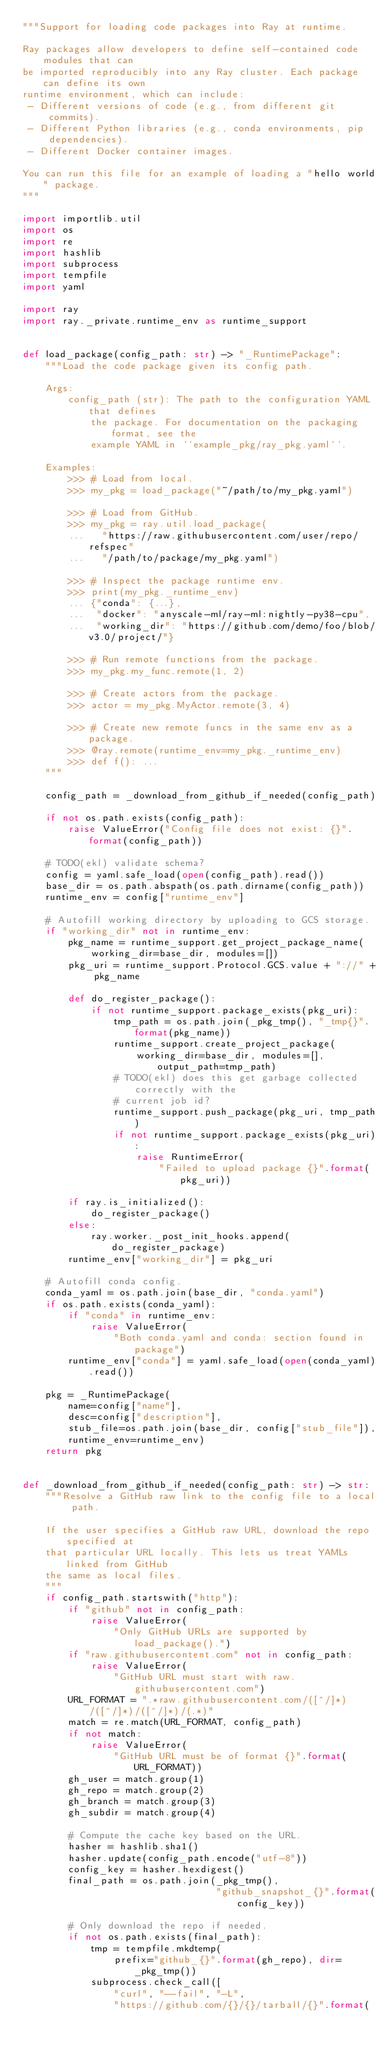Convert code to text. <code><loc_0><loc_0><loc_500><loc_500><_Python_>"""Support for loading code packages into Ray at runtime.

Ray packages allow developers to define self-contained code modules that can
be imported reproducibly into any Ray cluster. Each package can define its own
runtime environment, which can include:
 - Different versions of code (e.g., from different git commits).
 - Different Python libraries (e.g., conda environments, pip dependencies).
 - Different Docker container images.

You can run this file for an example of loading a "hello world" package.
"""

import importlib.util
import os
import re
import hashlib
import subprocess
import tempfile
import yaml

import ray
import ray._private.runtime_env as runtime_support


def load_package(config_path: str) -> "_RuntimePackage":
    """Load the code package given its config path.

    Args:
        config_path (str): The path to the configuration YAML that defines
            the package. For documentation on the packaging format, see the
            example YAML in ``example_pkg/ray_pkg.yaml``.

    Examples:
        >>> # Load from local.
        >>> my_pkg = load_package("~/path/to/my_pkg.yaml")

        >>> # Load from GitHub.
        >>> my_pkg = ray.util.load_package(
        ...   "https://raw.githubusercontent.com/user/repo/refspec"
        ...   "/path/to/package/my_pkg.yaml")

        >>> # Inspect the package runtime env.
        >>> print(my_pkg._runtime_env)
        ... {"conda": {...},
        ...  "docker": "anyscale-ml/ray-ml:nightly-py38-cpu",
        ...  "working_dir": "https://github.com/demo/foo/blob/v3.0/project/"}

        >>> # Run remote functions from the package.
        >>> my_pkg.my_func.remote(1, 2)

        >>> # Create actors from the package.
        >>> actor = my_pkg.MyActor.remote(3, 4)

        >>> # Create new remote funcs in the same env as a package.
        >>> @ray.remote(runtime_env=my_pkg._runtime_env)
        >>> def f(): ...
    """

    config_path = _download_from_github_if_needed(config_path)

    if not os.path.exists(config_path):
        raise ValueError("Config file does not exist: {}".format(config_path))

    # TODO(ekl) validate schema?
    config = yaml.safe_load(open(config_path).read())
    base_dir = os.path.abspath(os.path.dirname(config_path))
    runtime_env = config["runtime_env"]

    # Autofill working directory by uploading to GCS storage.
    if "working_dir" not in runtime_env:
        pkg_name = runtime_support.get_project_package_name(
            working_dir=base_dir, modules=[])
        pkg_uri = runtime_support.Protocol.GCS.value + "://" + pkg_name

        def do_register_package():
            if not runtime_support.package_exists(pkg_uri):
                tmp_path = os.path.join(_pkg_tmp(), "_tmp{}".format(pkg_name))
                runtime_support.create_project_package(
                    working_dir=base_dir, modules=[], output_path=tmp_path)
                # TODO(ekl) does this get garbage collected correctly with the
                # current job id?
                runtime_support.push_package(pkg_uri, tmp_path)
                if not runtime_support.package_exists(pkg_uri):
                    raise RuntimeError(
                        "Failed to upload package {}".format(pkg_uri))

        if ray.is_initialized():
            do_register_package()
        else:
            ray.worker._post_init_hooks.append(do_register_package)
        runtime_env["working_dir"] = pkg_uri

    # Autofill conda config.
    conda_yaml = os.path.join(base_dir, "conda.yaml")
    if os.path.exists(conda_yaml):
        if "conda" in runtime_env:
            raise ValueError(
                "Both conda.yaml and conda: section found in package")
        runtime_env["conda"] = yaml.safe_load(open(conda_yaml).read())

    pkg = _RuntimePackage(
        name=config["name"],
        desc=config["description"],
        stub_file=os.path.join(base_dir, config["stub_file"]),
        runtime_env=runtime_env)
    return pkg


def _download_from_github_if_needed(config_path: str) -> str:
    """Resolve a GitHub raw link to the config file to a local path.

    If the user specifies a GitHub raw URL, download the repo specified at
    that particular URL locally. This lets us treat YAMLs linked from GitHub
    the same as local files.
    """
    if config_path.startswith("http"):
        if "github" not in config_path:
            raise ValueError(
                "Only GitHub URLs are supported by load_package().")
        if "raw.githubusercontent.com" not in config_path:
            raise ValueError(
                "GitHub URL must start with raw.githubusercontent.com")
        URL_FORMAT = ".*raw.githubusercontent.com/([^/]*)/([^/]*)/([^/]*)/(.*)"
        match = re.match(URL_FORMAT, config_path)
        if not match:
            raise ValueError(
                "GitHub URL must be of format {}".format(URL_FORMAT))
        gh_user = match.group(1)
        gh_repo = match.group(2)
        gh_branch = match.group(3)
        gh_subdir = match.group(4)

        # Compute the cache key based on the URL.
        hasher = hashlib.sha1()
        hasher.update(config_path.encode("utf-8"))
        config_key = hasher.hexdigest()
        final_path = os.path.join(_pkg_tmp(),
                                  "github_snapshot_{}".format(config_key))

        # Only download the repo if needed.
        if not os.path.exists(final_path):
            tmp = tempfile.mkdtemp(
                prefix="github_{}".format(gh_repo), dir=_pkg_tmp())
            subprocess.check_call([
                "curl", "--fail", "-L",
                "https://github.com/{}/{}/tarball/{}".format(</code> 